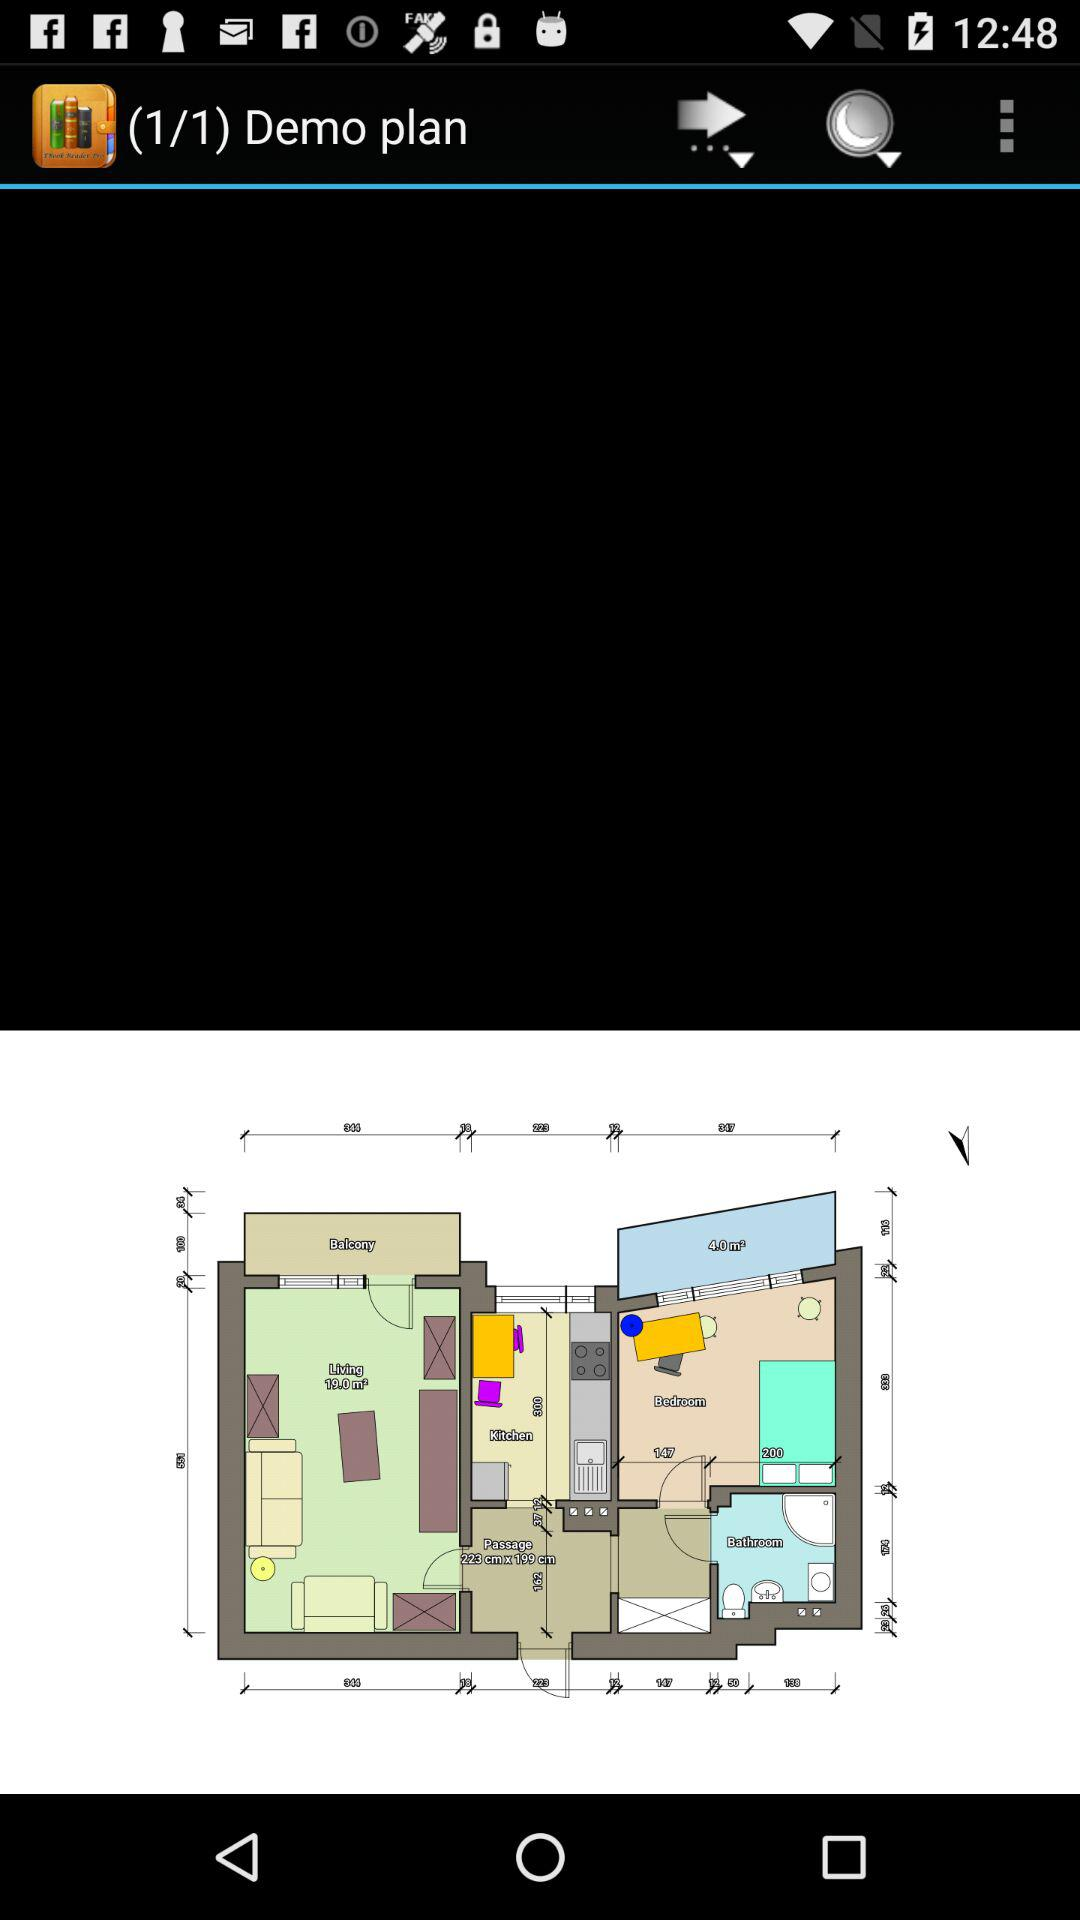Which is the current demo plan? The current demo plan is 1. 